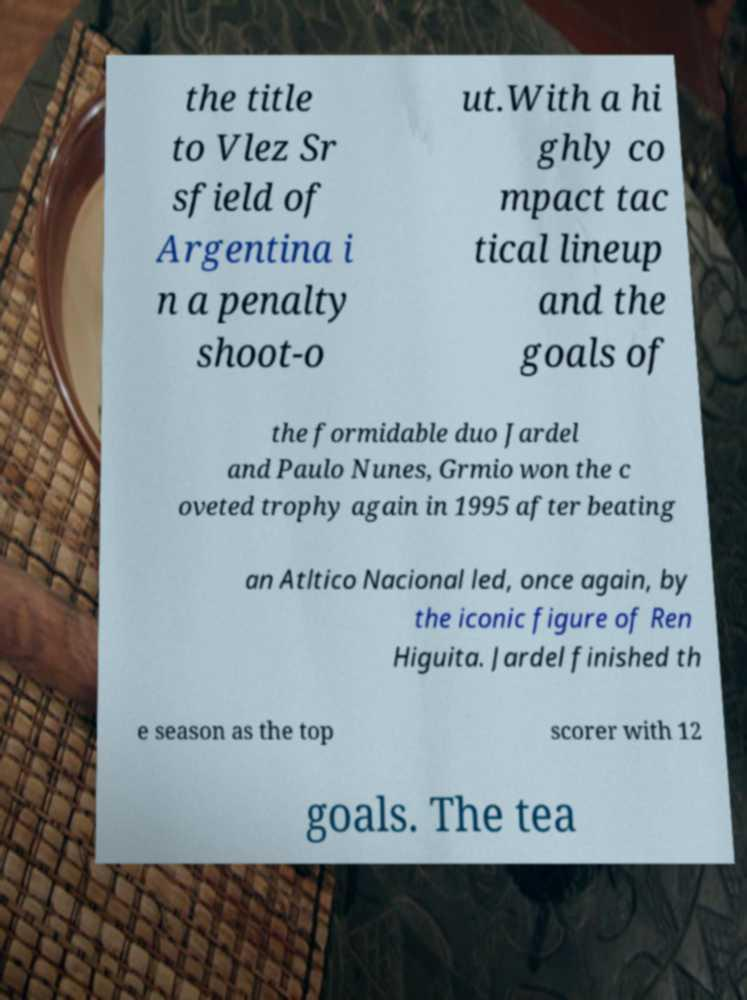Could you extract and type out the text from this image? the title to Vlez Sr sfield of Argentina i n a penalty shoot-o ut.With a hi ghly co mpact tac tical lineup and the goals of the formidable duo Jardel and Paulo Nunes, Grmio won the c oveted trophy again in 1995 after beating an Atltico Nacional led, once again, by the iconic figure of Ren Higuita. Jardel finished th e season as the top scorer with 12 goals. The tea 